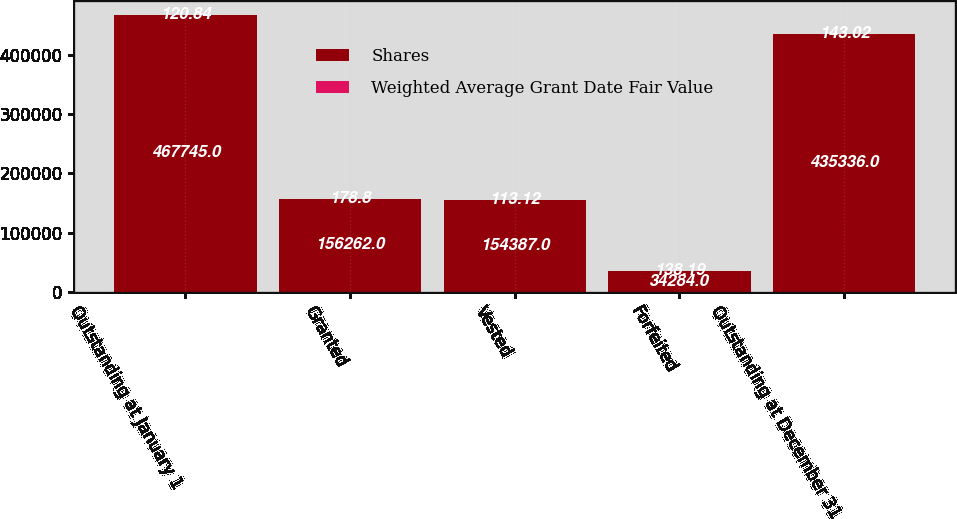<chart> <loc_0><loc_0><loc_500><loc_500><stacked_bar_chart><ecel><fcel>Outstanding at January 1<fcel>Granted<fcel>Vested<fcel>Forfeited<fcel>Outstanding at December 31<nl><fcel>Shares<fcel>467745<fcel>156262<fcel>154387<fcel>34284<fcel>435336<nl><fcel>Weighted Average Grant Date Fair Value<fcel>120.84<fcel>178.8<fcel>113.12<fcel>138.19<fcel>143.02<nl></chart> 